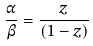<formula> <loc_0><loc_0><loc_500><loc_500>\frac { \alpha } { \beta } = \frac { z } { ( 1 - z ) }</formula> 